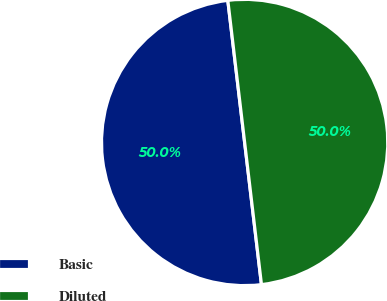<chart> <loc_0><loc_0><loc_500><loc_500><pie_chart><fcel>Basic<fcel>Diluted<nl><fcel>50.0%<fcel>50.0%<nl></chart> 